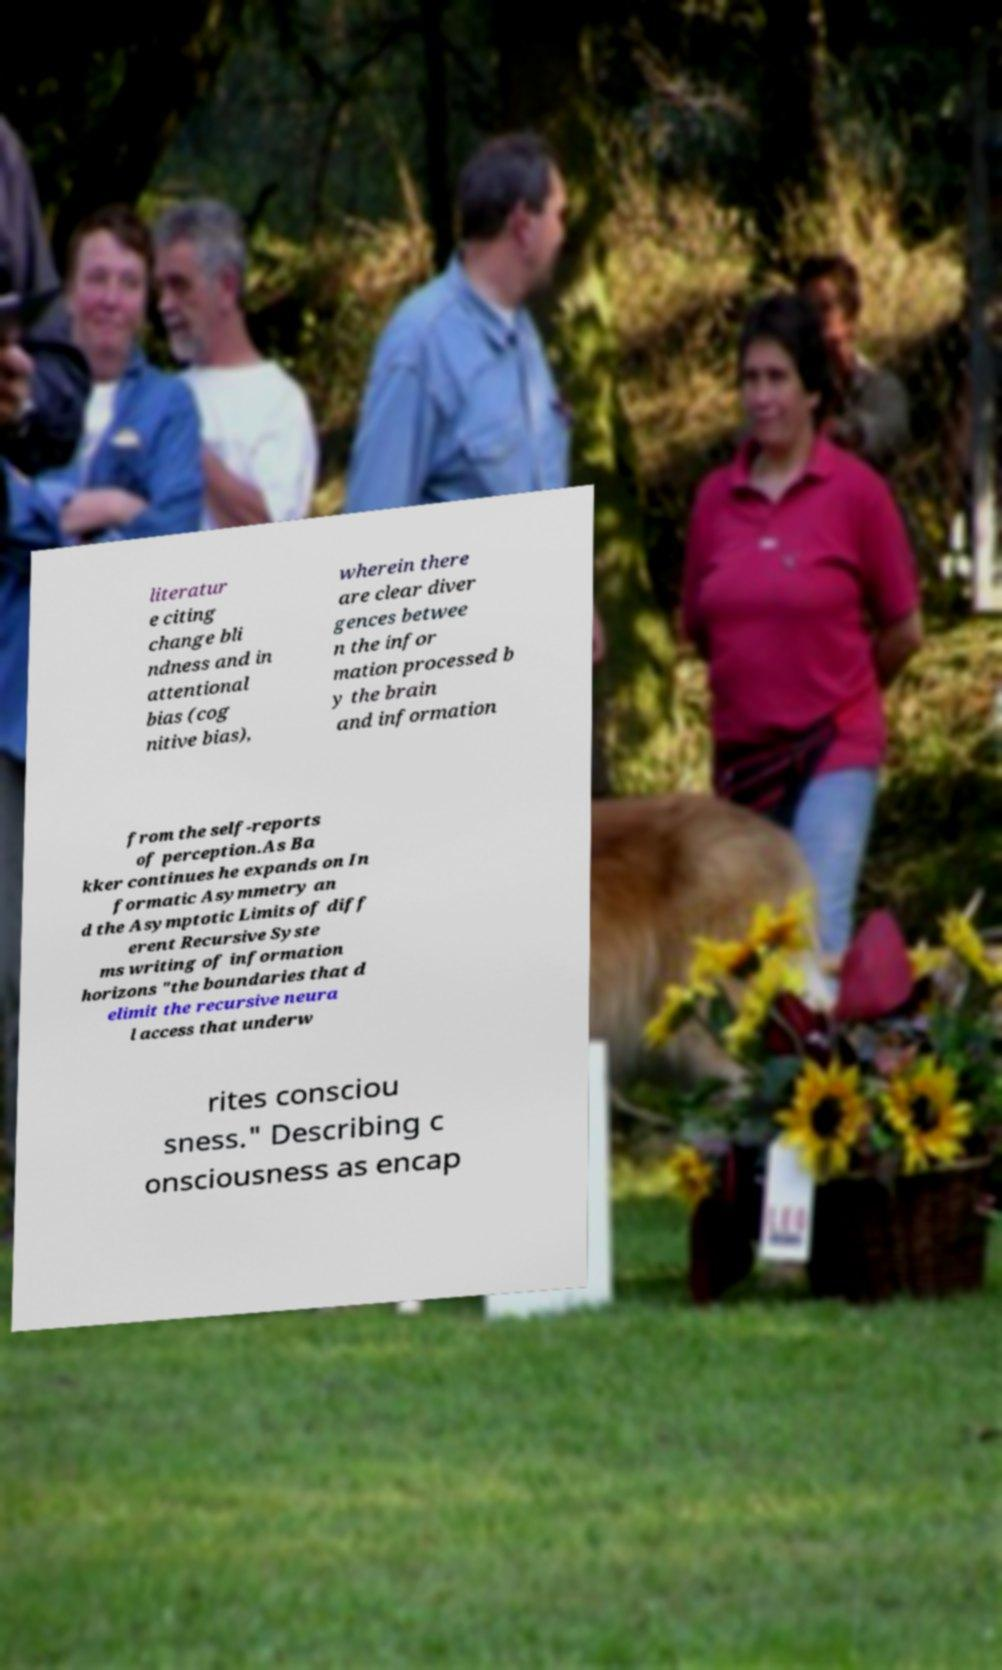Can you read and provide the text displayed in the image?This photo seems to have some interesting text. Can you extract and type it out for me? literatur e citing change bli ndness and in attentional bias (cog nitive bias), wherein there are clear diver gences betwee n the infor mation processed b y the brain and information from the self-reports of perception.As Ba kker continues he expands on In formatic Asymmetry an d the Asymptotic Limits of diff erent Recursive Syste ms writing of information horizons "the boundaries that d elimit the recursive neura l access that underw rites consciou sness." Describing c onsciousness as encap 